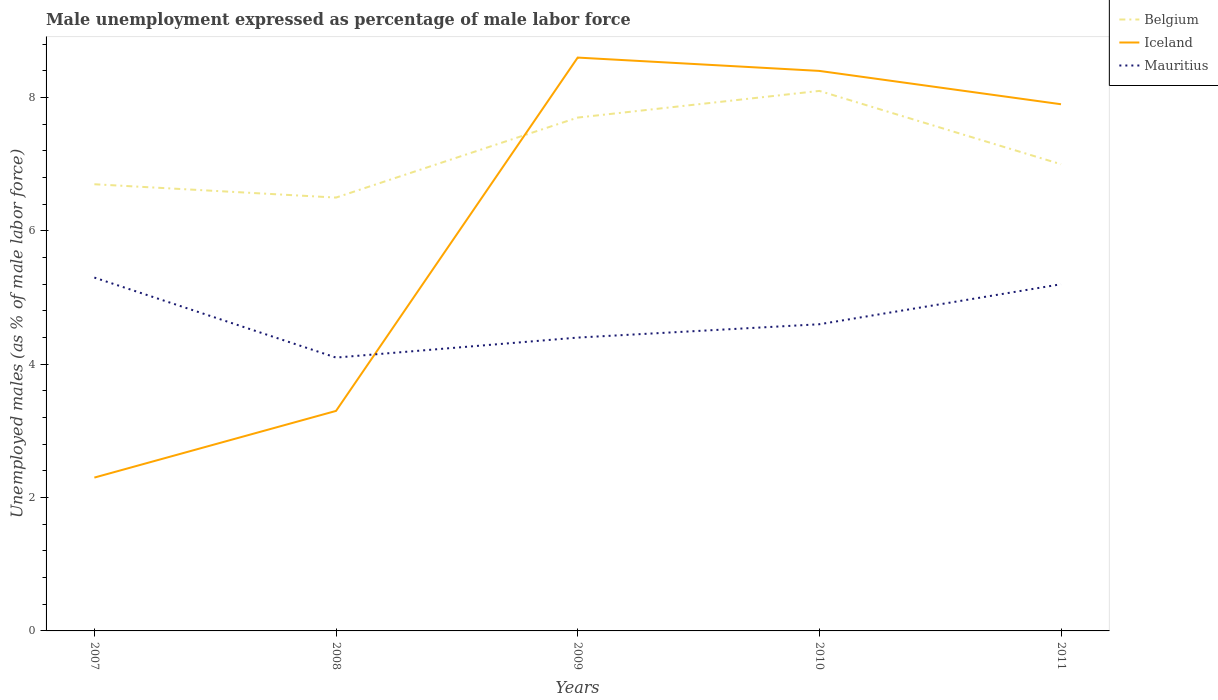Does the line corresponding to Mauritius intersect with the line corresponding to Iceland?
Keep it short and to the point. Yes. Across all years, what is the maximum unemployment in males in in Iceland?
Provide a succinct answer. 2.3. What is the total unemployment in males in in Mauritius in the graph?
Give a very brief answer. 0.9. What is the difference between the highest and the second highest unemployment in males in in Belgium?
Offer a terse response. 1.6. What is the difference between the highest and the lowest unemployment in males in in Iceland?
Your response must be concise. 3. Are the values on the major ticks of Y-axis written in scientific E-notation?
Make the answer very short. No. Does the graph contain any zero values?
Your answer should be very brief. No. Does the graph contain grids?
Your answer should be very brief. No. How are the legend labels stacked?
Provide a succinct answer. Vertical. What is the title of the graph?
Give a very brief answer. Male unemployment expressed as percentage of male labor force. What is the label or title of the X-axis?
Keep it short and to the point. Years. What is the label or title of the Y-axis?
Ensure brevity in your answer.  Unemployed males (as % of male labor force). What is the Unemployed males (as % of male labor force) of Belgium in 2007?
Provide a succinct answer. 6.7. What is the Unemployed males (as % of male labor force) of Iceland in 2007?
Make the answer very short. 2.3. What is the Unemployed males (as % of male labor force) in Mauritius in 2007?
Provide a succinct answer. 5.3. What is the Unemployed males (as % of male labor force) of Belgium in 2008?
Your answer should be compact. 6.5. What is the Unemployed males (as % of male labor force) in Iceland in 2008?
Give a very brief answer. 3.3. What is the Unemployed males (as % of male labor force) in Mauritius in 2008?
Give a very brief answer. 4.1. What is the Unemployed males (as % of male labor force) of Belgium in 2009?
Offer a very short reply. 7.7. What is the Unemployed males (as % of male labor force) of Iceland in 2009?
Provide a short and direct response. 8.6. What is the Unemployed males (as % of male labor force) of Mauritius in 2009?
Offer a terse response. 4.4. What is the Unemployed males (as % of male labor force) in Belgium in 2010?
Your answer should be compact. 8.1. What is the Unemployed males (as % of male labor force) in Iceland in 2010?
Your response must be concise. 8.4. What is the Unemployed males (as % of male labor force) in Mauritius in 2010?
Your answer should be compact. 4.6. What is the Unemployed males (as % of male labor force) in Belgium in 2011?
Provide a short and direct response. 7. What is the Unemployed males (as % of male labor force) in Iceland in 2011?
Ensure brevity in your answer.  7.9. What is the Unemployed males (as % of male labor force) in Mauritius in 2011?
Keep it short and to the point. 5.2. Across all years, what is the maximum Unemployed males (as % of male labor force) of Belgium?
Offer a terse response. 8.1. Across all years, what is the maximum Unemployed males (as % of male labor force) in Iceland?
Make the answer very short. 8.6. Across all years, what is the maximum Unemployed males (as % of male labor force) in Mauritius?
Offer a terse response. 5.3. Across all years, what is the minimum Unemployed males (as % of male labor force) in Iceland?
Keep it short and to the point. 2.3. Across all years, what is the minimum Unemployed males (as % of male labor force) in Mauritius?
Your answer should be very brief. 4.1. What is the total Unemployed males (as % of male labor force) in Belgium in the graph?
Provide a succinct answer. 36. What is the total Unemployed males (as % of male labor force) in Iceland in the graph?
Your answer should be compact. 30.5. What is the total Unemployed males (as % of male labor force) in Mauritius in the graph?
Your response must be concise. 23.6. What is the difference between the Unemployed males (as % of male labor force) of Iceland in 2007 and that in 2008?
Keep it short and to the point. -1. What is the difference between the Unemployed males (as % of male labor force) of Mauritius in 2007 and that in 2009?
Keep it short and to the point. 0.9. What is the difference between the Unemployed males (as % of male labor force) in Belgium in 2007 and that in 2010?
Ensure brevity in your answer.  -1.4. What is the difference between the Unemployed males (as % of male labor force) of Iceland in 2007 and that in 2011?
Provide a succinct answer. -5.6. What is the difference between the Unemployed males (as % of male labor force) of Mauritius in 2007 and that in 2011?
Offer a terse response. 0.1. What is the difference between the Unemployed males (as % of male labor force) of Belgium in 2008 and that in 2009?
Your response must be concise. -1.2. What is the difference between the Unemployed males (as % of male labor force) of Mauritius in 2008 and that in 2009?
Make the answer very short. -0.3. What is the difference between the Unemployed males (as % of male labor force) of Mauritius in 2008 and that in 2010?
Ensure brevity in your answer.  -0.5. What is the difference between the Unemployed males (as % of male labor force) in Mauritius in 2008 and that in 2011?
Provide a short and direct response. -1.1. What is the difference between the Unemployed males (as % of male labor force) of Mauritius in 2009 and that in 2010?
Offer a terse response. -0.2. What is the difference between the Unemployed males (as % of male labor force) in Belgium in 2009 and that in 2011?
Your answer should be compact. 0.7. What is the difference between the Unemployed males (as % of male labor force) in Belgium in 2010 and that in 2011?
Offer a terse response. 1.1. What is the difference between the Unemployed males (as % of male labor force) of Iceland in 2010 and that in 2011?
Your answer should be very brief. 0.5. What is the difference between the Unemployed males (as % of male labor force) of Mauritius in 2010 and that in 2011?
Your answer should be compact. -0.6. What is the difference between the Unemployed males (as % of male labor force) of Belgium in 2007 and the Unemployed males (as % of male labor force) of Iceland in 2009?
Give a very brief answer. -1.9. What is the difference between the Unemployed males (as % of male labor force) in Iceland in 2007 and the Unemployed males (as % of male labor force) in Mauritius in 2009?
Offer a very short reply. -2.1. What is the difference between the Unemployed males (as % of male labor force) of Belgium in 2007 and the Unemployed males (as % of male labor force) of Iceland in 2010?
Your response must be concise. -1.7. What is the difference between the Unemployed males (as % of male labor force) of Belgium in 2007 and the Unemployed males (as % of male labor force) of Mauritius in 2010?
Provide a short and direct response. 2.1. What is the difference between the Unemployed males (as % of male labor force) of Belgium in 2007 and the Unemployed males (as % of male labor force) of Mauritius in 2011?
Your answer should be very brief. 1.5. What is the difference between the Unemployed males (as % of male labor force) of Iceland in 2007 and the Unemployed males (as % of male labor force) of Mauritius in 2011?
Your response must be concise. -2.9. What is the difference between the Unemployed males (as % of male labor force) of Belgium in 2008 and the Unemployed males (as % of male labor force) of Mauritius in 2009?
Keep it short and to the point. 2.1. What is the difference between the Unemployed males (as % of male labor force) of Iceland in 2008 and the Unemployed males (as % of male labor force) of Mauritius in 2010?
Keep it short and to the point. -1.3. What is the difference between the Unemployed males (as % of male labor force) of Belgium in 2008 and the Unemployed males (as % of male labor force) of Iceland in 2011?
Offer a terse response. -1.4. What is the difference between the Unemployed males (as % of male labor force) in Belgium in 2008 and the Unemployed males (as % of male labor force) in Mauritius in 2011?
Give a very brief answer. 1.3. What is the difference between the Unemployed males (as % of male labor force) of Belgium in 2009 and the Unemployed males (as % of male labor force) of Iceland in 2010?
Your answer should be very brief. -0.7. What is the difference between the Unemployed males (as % of male labor force) of Belgium in 2009 and the Unemployed males (as % of male labor force) of Mauritius in 2010?
Offer a terse response. 3.1. What is the difference between the Unemployed males (as % of male labor force) in Belgium in 2009 and the Unemployed males (as % of male labor force) in Mauritius in 2011?
Provide a short and direct response. 2.5. What is the difference between the Unemployed males (as % of male labor force) of Iceland in 2009 and the Unemployed males (as % of male labor force) of Mauritius in 2011?
Give a very brief answer. 3.4. What is the difference between the Unemployed males (as % of male labor force) of Belgium in 2010 and the Unemployed males (as % of male labor force) of Iceland in 2011?
Make the answer very short. 0.2. What is the average Unemployed males (as % of male labor force) of Belgium per year?
Offer a very short reply. 7.2. What is the average Unemployed males (as % of male labor force) of Mauritius per year?
Keep it short and to the point. 4.72. In the year 2007, what is the difference between the Unemployed males (as % of male labor force) in Belgium and Unemployed males (as % of male labor force) in Mauritius?
Make the answer very short. 1.4. In the year 2007, what is the difference between the Unemployed males (as % of male labor force) of Iceland and Unemployed males (as % of male labor force) of Mauritius?
Your answer should be compact. -3. In the year 2008, what is the difference between the Unemployed males (as % of male labor force) of Iceland and Unemployed males (as % of male labor force) of Mauritius?
Provide a succinct answer. -0.8. In the year 2009, what is the difference between the Unemployed males (as % of male labor force) of Belgium and Unemployed males (as % of male labor force) of Iceland?
Your response must be concise. -0.9. In the year 2009, what is the difference between the Unemployed males (as % of male labor force) in Iceland and Unemployed males (as % of male labor force) in Mauritius?
Provide a succinct answer. 4.2. In the year 2010, what is the difference between the Unemployed males (as % of male labor force) of Belgium and Unemployed males (as % of male labor force) of Iceland?
Your answer should be compact. -0.3. In the year 2010, what is the difference between the Unemployed males (as % of male labor force) of Iceland and Unemployed males (as % of male labor force) of Mauritius?
Your answer should be very brief. 3.8. In the year 2011, what is the difference between the Unemployed males (as % of male labor force) of Belgium and Unemployed males (as % of male labor force) of Iceland?
Your answer should be compact. -0.9. In the year 2011, what is the difference between the Unemployed males (as % of male labor force) of Belgium and Unemployed males (as % of male labor force) of Mauritius?
Provide a short and direct response. 1.8. What is the ratio of the Unemployed males (as % of male labor force) of Belgium in 2007 to that in 2008?
Offer a terse response. 1.03. What is the ratio of the Unemployed males (as % of male labor force) of Iceland in 2007 to that in 2008?
Your answer should be compact. 0.7. What is the ratio of the Unemployed males (as % of male labor force) of Mauritius in 2007 to that in 2008?
Your answer should be compact. 1.29. What is the ratio of the Unemployed males (as % of male labor force) of Belgium in 2007 to that in 2009?
Ensure brevity in your answer.  0.87. What is the ratio of the Unemployed males (as % of male labor force) of Iceland in 2007 to that in 2009?
Provide a succinct answer. 0.27. What is the ratio of the Unemployed males (as % of male labor force) of Mauritius in 2007 to that in 2009?
Your answer should be compact. 1.2. What is the ratio of the Unemployed males (as % of male labor force) of Belgium in 2007 to that in 2010?
Provide a short and direct response. 0.83. What is the ratio of the Unemployed males (as % of male labor force) in Iceland in 2007 to that in 2010?
Offer a very short reply. 0.27. What is the ratio of the Unemployed males (as % of male labor force) of Mauritius in 2007 to that in 2010?
Your answer should be compact. 1.15. What is the ratio of the Unemployed males (as % of male labor force) of Belgium in 2007 to that in 2011?
Give a very brief answer. 0.96. What is the ratio of the Unemployed males (as % of male labor force) of Iceland in 2007 to that in 2011?
Ensure brevity in your answer.  0.29. What is the ratio of the Unemployed males (as % of male labor force) of Mauritius in 2007 to that in 2011?
Offer a very short reply. 1.02. What is the ratio of the Unemployed males (as % of male labor force) of Belgium in 2008 to that in 2009?
Your answer should be very brief. 0.84. What is the ratio of the Unemployed males (as % of male labor force) of Iceland in 2008 to that in 2009?
Your answer should be very brief. 0.38. What is the ratio of the Unemployed males (as % of male labor force) in Mauritius in 2008 to that in 2009?
Provide a succinct answer. 0.93. What is the ratio of the Unemployed males (as % of male labor force) in Belgium in 2008 to that in 2010?
Give a very brief answer. 0.8. What is the ratio of the Unemployed males (as % of male labor force) in Iceland in 2008 to that in 2010?
Keep it short and to the point. 0.39. What is the ratio of the Unemployed males (as % of male labor force) in Mauritius in 2008 to that in 2010?
Your answer should be very brief. 0.89. What is the ratio of the Unemployed males (as % of male labor force) of Iceland in 2008 to that in 2011?
Provide a short and direct response. 0.42. What is the ratio of the Unemployed males (as % of male labor force) of Mauritius in 2008 to that in 2011?
Your answer should be compact. 0.79. What is the ratio of the Unemployed males (as % of male labor force) in Belgium in 2009 to that in 2010?
Make the answer very short. 0.95. What is the ratio of the Unemployed males (as % of male labor force) in Iceland in 2009 to that in 2010?
Provide a short and direct response. 1.02. What is the ratio of the Unemployed males (as % of male labor force) in Mauritius in 2009 to that in 2010?
Offer a very short reply. 0.96. What is the ratio of the Unemployed males (as % of male labor force) in Belgium in 2009 to that in 2011?
Offer a very short reply. 1.1. What is the ratio of the Unemployed males (as % of male labor force) of Iceland in 2009 to that in 2011?
Keep it short and to the point. 1.09. What is the ratio of the Unemployed males (as % of male labor force) of Mauritius in 2009 to that in 2011?
Your response must be concise. 0.85. What is the ratio of the Unemployed males (as % of male labor force) in Belgium in 2010 to that in 2011?
Your answer should be compact. 1.16. What is the ratio of the Unemployed males (as % of male labor force) of Iceland in 2010 to that in 2011?
Provide a succinct answer. 1.06. What is the ratio of the Unemployed males (as % of male labor force) of Mauritius in 2010 to that in 2011?
Your answer should be compact. 0.88. What is the difference between the highest and the second highest Unemployed males (as % of male labor force) of Iceland?
Ensure brevity in your answer.  0.2. What is the difference between the highest and the second highest Unemployed males (as % of male labor force) of Mauritius?
Offer a terse response. 0.1. What is the difference between the highest and the lowest Unemployed males (as % of male labor force) in Iceland?
Make the answer very short. 6.3. What is the difference between the highest and the lowest Unemployed males (as % of male labor force) in Mauritius?
Ensure brevity in your answer.  1.2. 